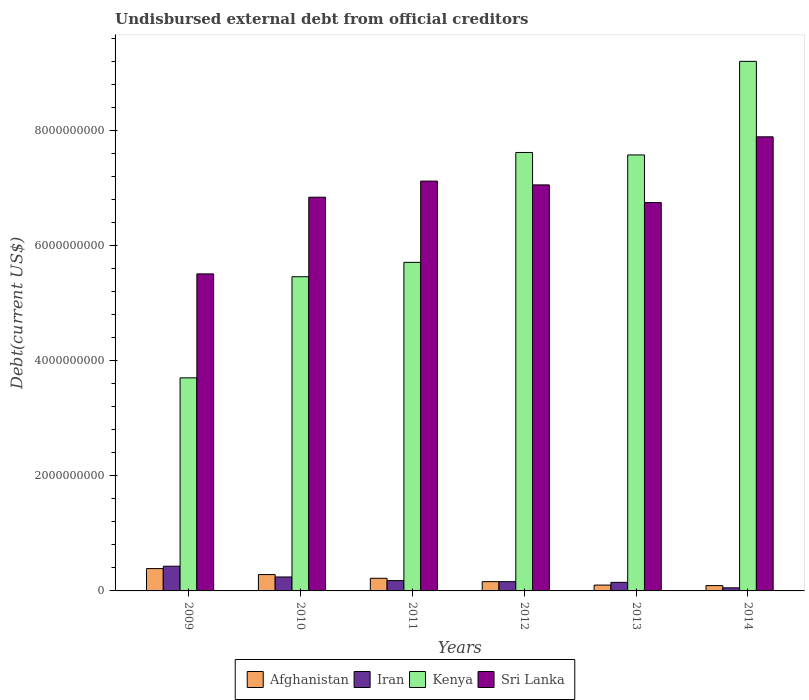How many different coloured bars are there?
Your response must be concise. 4. How many groups of bars are there?
Keep it short and to the point. 6. Are the number of bars per tick equal to the number of legend labels?
Provide a short and direct response. Yes. How many bars are there on the 1st tick from the left?
Keep it short and to the point. 4. What is the label of the 1st group of bars from the left?
Your answer should be very brief. 2009. What is the total debt in Kenya in 2009?
Offer a terse response. 3.70e+09. Across all years, what is the maximum total debt in Afghanistan?
Offer a very short reply. 3.88e+08. Across all years, what is the minimum total debt in Iran?
Provide a short and direct response. 5.37e+07. In which year was the total debt in Iran minimum?
Make the answer very short. 2014. What is the total total debt in Afghanistan in the graph?
Offer a very short reply. 1.25e+09. What is the difference between the total debt in Sri Lanka in 2013 and that in 2014?
Keep it short and to the point. -1.14e+09. What is the difference between the total debt in Sri Lanka in 2011 and the total debt in Kenya in 2014?
Provide a succinct answer. -2.08e+09. What is the average total debt in Sri Lanka per year?
Ensure brevity in your answer.  6.87e+09. In the year 2014, what is the difference between the total debt in Kenya and total debt in Iran?
Your answer should be compact. 9.15e+09. What is the ratio of the total debt in Sri Lanka in 2009 to that in 2014?
Ensure brevity in your answer.  0.7. What is the difference between the highest and the second highest total debt in Iran?
Make the answer very short. 1.87e+08. What is the difference between the highest and the lowest total debt in Iran?
Ensure brevity in your answer.  3.76e+08. What does the 4th bar from the left in 2012 represents?
Keep it short and to the point. Sri Lanka. What does the 1st bar from the right in 2009 represents?
Offer a terse response. Sri Lanka. Is it the case that in every year, the sum of the total debt in Afghanistan and total debt in Sri Lanka is greater than the total debt in Iran?
Give a very brief answer. Yes. Are all the bars in the graph horizontal?
Offer a very short reply. No. How many years are there in the graph?
Ensure brevity in your answer.  6. Are the values on the major ticks of Y-axis written in scientific E-notation?
Keep it short and to the point. No. How many legend labels are there?
Your answer should be compact. 4. What is the title of the graph?
Give a very brief answer. Undisbursed external debt from official creditors. What is the label or title of the Y-axis?
Offer a very short reply. Debt(current US$). What is the Debt(current US$) of Afghanistan in 2009?
Offer a very short reply. 3.88e+08. What is the Debt(current US$) of Iran in 2009?
Make the answer very short. 4.29e+08. What is the Debt(current US$) of Kenya in 2009?
Provide a succinct answer. 3.70e+09. What is the Debt(current US$) in Sri Lanka in 2009?
Your response must be concise. 5.51e+09. What is the Debt(current US$) in Afghanistan in 2010?
Your answer should be compact. 2.84e+08. What is the Debt(current US$) in Iran in 2010?
Offer a very short reply. 2.43e+08. What is the Debt(current US$) in Kenya in 2010?
Give a very brief answer. 5.46e+09. What is the Debt(current US$) in Sri Lanka in 2010?
Make the answer very short. 6.85e+09. What is the Debt(current US$) of Afghanistan in 2011?
Your answer should be very brief. 2.20e+08. What is the Debt(current US$) in Iran in 2011?
Make the answer very short. 1.79e+08. What is the Debt(current US$) in Kenya in 2011?
Offer a very short reply. 5.71e+09. What is the Debt(current US$) in Sri Lanka in 2011?
Provide a succinct answer. 7.13e+09. What is the Debt(current US$) of Afghanistan in 2012?
Provide a short and direct response. 1.61e+08. What is the Debt(current US$) in Iran in 2012?
Give a very brief answer. 1.61e+08. What is the Debt(current US$) of Kenya in 2012?
Make the answer very short. 7.62e+09. What is the Debt(current US$) in Sri Lanka in 2012?
Offer a terse response. 7.06e+09. What is the Debt(current US$) in Afghanistan in 2013?
Make the answer very short. 1.02e+08. What is the Debt(current US$) of Iran in 2013?
Provide a succinct answer. 1.49e+08. What is the Debt(current US$) of Kenya in 2013?
Provide a short and direct response. 7.58e+09. What is the Debt(current US$) in Sri Lanka in 2013?
Your response must be concise. 6.75e+09. What is the Debt(current US$) of Afghanistan in 2014?
Offer a very short reply. 9.24e+07. What is the Debt(current US$) in Iran in 2014?
Offer a terse response. 5.37e+07. What is the Debt(current US$) in Kenya in 2014?
Ensure brevity in your answer.  9.21e+09. What is the Debt(current US$) of Sri Lanka in 2014?
Your answer should be very brief. 7.90e+09. Across all years, what is the maximum Debt(current US$) of Afghanistan?
Make the answer very short. 3.88e+08. Across all years, what is the maximum Debt(current US$) in Iran?
Offer a very short reply. 4.29e+08. Across all years, what is the maximum Debt(current US$) of Kenya?
Provide a succinct answer. 9.21e+09. Across all years, what is the maximum Debt(current US$) in Sri Lanka?
Provide a short and direct response. 7.90e+09. Across all years, what is the minimum Debt(current US$) of Afghanistan?
Make the answer very short. 9.24e+07. Across all years, what is the minimum Debt(current US$) in Iran?
Offer a very short reply. 5.37e+07. Across all years, what is the minimum Debt(current US$) of Kenya?
Make the answer very short. 3.70e+09. Across all years, what is the minimum Debt(current US$) of Sri Lanka?
Give a very brief answer. 5.51e+09. What is the total Debt(current US$) in Afghanistan in the graph?
Your response must be concise. 1.25e+09. What is the total Debt(current US$) of Iran in the graph?
Provide a succinct answer. 1.21e+09. What is the total Debt(current US$) of Kenya in the graph?
Offer a terse response. 3.93e+1. What is the total Debt(current US$) in Sri Lanka in the graph?
Provide a short and direct response. 4.12e+1. What is the difference between the Debt(current US$) of Afghanistan in 2009 and that in 2010?
Offer a very short reply. 1.04e+08. What is the difference between the Debt(current US$) of Iran in 2009 and that in 2010?
Make the answer very short. 1.87e+08. What is the difference between the Debt(current US$) in Kenya in 2009 and that in 2010?
Give a very brief answer. -1.76e+09. What is the difference between the Debt(current US$) of Sri Lanka in 2009 and that in 2010?
Offer a very short reply. -1.33e+09. What is the difference between the Debt(current US$) of Afghanistan in 2009 and that in 2011?
Ensure brevity in your answer.  1.68e+08. What is the difference between the Debt(current US$) in Iran in 2009 and that in 2011?
Offer a terse response. 2.50e+08. What is the difference between the Debt(current US$) of Kenya in 2009 and that in 2011?
Offer a terse response. -2.01e+09. What is the difference between the Debt(current US$) of Sri Lanka in 2009 and that in 2011?
Your answer should be compact. -1.61e+09. What is the difference between the Debt(current US$) of Afghanistan in 2009 and that in 2012?
Your answer should be compact. 2.27e+08. What is the difference between the Debt(current US$) of Iran in 2009 and that in 2012?
Ensure brevity in your answer.  2.68e+08. What is the difference between the Debt(current US$) in Kenya in 2009 and that in 2012?
Your answer should be compact. -3.92e+09. What is the difference between the Debt(current US$) in Sri Lanka in 2009 and that in 2012?
Provide a short and direct response. -1.55e+09. What is the difference between the Debt(current US$) of Afghanistan in 2009 and that in 2013?
Offer a terse response. 2.87e+08. What is the difference between the Debt(current US$) of Iran in 2009 and that in 2013?
Offer a very short reply. 2.80e+08. What is the difference between the Debt(current US$) in Kenya in 2009 and that in 2013?
Give a very brief answer. -3.88e+09. What is the difference between the Debt(current US$) in Sri Lanka in 2009 and that in 2013?
Ensure brevity in your answer.  -1.24e+09. What is the difference between the Debt(current US$) in Afghanistan in 2009 and that in 2014?
Your response must be concise. 2.96e+08. What is the difference between the Debt(current US$) of Iran in 2009 and that in 2014?
Make the answer very short. 3.76e+08. What is the difference between the Debt(current US$) of Kenya in 2009 and that in 2014?
Provide a succinct answer. -5.50e+09. What is the difference between the Debt(current US$) in Sri Lanka in 2009 and that in 2014?
Provide a short and direct response. -2.38e+09. What is the difference between the Debt(current US$) of Afghanistan in 2010 and that in 2011?
Offer a terse response. 6.44e+07. What is the difference between the Debt(current US$) of Iran in 2010 and that in 2011?
Give a very brief answer. 6.32e+07. What is the difference between the Debt(current US$) of Kenya in 2010 and that in 2011?
Provide a succinct answer. -2.50e+08. What is the difference between the Debt(current US$) of Sri Lanka in 2010 and that in 2011?
Give a very brief answer. -2.80e+08. What is the difference between the Debt(current US$) of Afghanistan in 2010 and that in 2012?
Provide a short and direct response. 1.23e+08. What is the difference between the Debt(current US$) of Iran in 2010 and that in 2012?
Offer a very short reply. 8.17e+07. What is the difference between the Debt(current US$) in Kenya in 2010 and that in 2012?
Make the answer very short. -2.16e+09. What is the difference between the Debt(current US$) of Sri Lanka in 2010 and that in 2012?
Offer a very short reply. -2.14e+08. What is the difference between the Debt(current US$) of Afghanistan in 2010 and that in 2013?
Provide a short and direct response. 1.83e+08. What is the difference between the Debt(current US$) in Iran in 2010 and that in 2013?
Ensure brevity in your answer.  9.35e+07. What is the difference between the Debt(current US$) of Kenya in 2010 and that in 2013?
Give a very brief answer. -2.12e+09. What is the difference between the Debt(current US$) of Sri Lanka in 2010 and that in 2013?
Your answer should be very brief. 9.24e+07. What is the difference between the Debt(current US$) of Afghanistan in 2010 and that in 2014?
Give a very brief answer. 1.92e+08. What is the difference between the Debt(current US$) in Iran in 2010 and that in 2014?
Ensure brevity in your answer.  1.89e+08. What is the difference between the Debt(current US$) in Kenya in 2010 and that in 2014?
Provide a short and direct response. -3.74e+09. What is the difference between the Debt(current US$) of Sri Lanka in 2010 and that in 2014?
Offer a terse response. -1.05e+09. What is the difference between the Debt(current US$) in Afghanistan in 2011 and that in 2012?
Provide a succinct answer. 5.87e+07. What is the difference between the Debt(current US$) of Iran in 2011 and that in 2012?
Provide a succinct answer. 1.85e+07. What is the difference between the Debt(current US$) of Kenya in 2011 and that in 2012?
Provide a succinct answer. -1.91e+09. What is the difference between the Debt(current US$) of Sri Lanka in 2011 and that in 2012?
Make the answer very short. 6.60e+07. What is the difference between the Debt(current US$) in Afghanistan in 2011 and that in 2013?
Your answer should be very brief. 1.18e+08. What is the difference between the Debt(current US$) of Iran in 2011 and that in 2013?
Your response must be concise. 3.02e+07. What is the difference between the Debt(current US$) of Kenya in 2011 and that in 2013?
Ensure brevity in your answer.  -1.87e+09. What is the difference between the Debt(current US$) of Sri Lanka in 2011 and that in 2013?
Your answer should be compact. 3.73e+08. What is the difference between the Debt(current US$) of Afghanistan in 2011 and that in 2014?
Give a very brief answer. 1.28e+08. What is the difference between the Debt(current US$) of Iran in 2011 and that in 2014?
Make the answer very short. 1.26e+08. What is the difference between the Debt(current US$) of Kenya in 2011 and that in 2014?
Ensure brevity in your answer.  -3.49e+09. What is the difference between the Debt(current US$) of Sri Lanka in 2011 and that in 2014?
Offer a terse response. -7.70e+08. What is the difference between the Debt(current US$) of Afghanistan in 2012 and that in 2013?
Offer a terse response. 5.97e+07. What is the difference between the Debt(current US$) of Iran in 2012 and that in 2013?
Your response must be concise. 1.17e+07. What is the difference between the Debt(current US$) of Kenya in 2012 and that in 2013?
Make the answer very short. 4.27e+07. What is the difference between the Debt(current US$) of Sri Lanka in 2012 and that in 2013?
Provide a succinct answer. 3.07e+08. What is the difference between the Debt(current US$) in Afghanistan in 2012 and that in 2014?
Your response must be concise. 6.89e+07. What is the difference between the Debt(current US$) of Iran in 2012 and that in 2014?
Offer a very short reply. 1.07e+08. What is the difference between the Debt(current US$) of Kenya in 2012 and that in 2014?
Give a very brief answer. -1.58e+09. What is the difference between the Debt(current US$) of Sri Lanka in 2012 and that in 2014?
Your answer should be compact. -8.36e+08. What is the difference between the Debt(current US$) of Afghanistan in 2013 and that in 2014?
Your answer should be compact. 9.12e+06. What is the difference between the Debt(current US$) of Iran in 2013 and that in 2014?
Your answer should be compact. 9.54e+07. What is the difference between the Debt(current US$) in Kenya in 2013 and that in 2014?
Your answer should be very brief. -1.63e+09. What is the difference between the Debt(current US$) of Sri Lanka in 2013 and that in 2014?
Your answer should be very brief. -1.14e+09. What is the difference between the Debt(current US$) in Afghanistan in 2009 and the Debt(current US$) in Iran in 2010?
Ensure brevity in your answer.  1.46e+08. What is the difference between the Debt(current US$) in Afghanistan in 2009 and the Debt(current US$) in Kenya in 2010?
Provide a short and direct response. -5.07e+09. What is the difference between the Debt(current US$) of Afghanistan in 2009 and the Debt(current US$) of Sri Lanka in 2010?
Provide a short and direct response. -6.46e+09. What is the difference between the Debt(current US$) of Iran in 2009 and the Debt(current US$) of Kenya in 2010?
Offer a terse response. -5.03e+09. What is the difference between the Debt(current US$) in Iran in 2009 and the Debt(current US$) in Sri Lanka in 2010?
Ensure brevity in your answer.  -6.42e+09. What is the difference between the Debt(current US$) of Kenya in 2009 and the Debt(current US$) of Sri Lanka in 2010?
Provide a short and direct response. -3.14e+09. What is the difference between the Debt(current US$) of Afghanistan in 2009 and the Debt(current US$) of Iran in 2011?
Offer a very short reply. 2.09e+08. What is the difference between the Debt(current US$) in Afghanistan in 2009 and the Debt(current US$) in Kenya in 2011?
Keep it short and to the point. -5.32e+09. What is the difference between the Debt(current US$) in Afghanistan in 2009 and the Debt(current US$) in Sri Lanka in 2011?
Your answer should be compact. -6.74e+09. What is the difference between the Debt(current US$) in Iran in 2009 and the Debt(current US$) in Kenya in 2011?
Your answer should be compact. -5.28e+09. What is the difference between the Debt(current US$) in Iran in 2009 and the Debt(current US$) in Sri Lanka in 2011?
Provide a succinct answer. -6.70e+09. What is the difference between the Debt(current US$) of Kenya in 2009 and the Debt(current US$) of Sri Lanka in 2011?
Your response must be concise. -3.42e+09. What is the difference between the Debt(current US$) of Afghanistan in 2009 and the Debt(current US$) of Iran in 2012?
Provide a succinct answer. 2.28e+08. What is the difference between the Debt(current US$) of Afghanistan in 2009 and the Debt(current US$) of Kenya in 2012?
Keep it short and to the point. -7.24e+09. What is the difference between the Debt(current US$) of Afghanistan in 2009 and the Debt(current US$) of Sri Lanka in 2012?
Your response must be concise. -6.67e+09. What is the difference between the Debt(current US$) in Iran in 2009 and the Debt(current US$) in Kenya in 2012?
Make the answer very short. -7.19e+09. What is the difference between the Debt(current US$) in Iran in 2009 and the Debt(current US$) in Sri Lanka in 2012?
Your answer should be very brief. -6.63e+09. What is the difference between the Debt(current US$) of Kenya in 2009 and the Debt(current US$) of Sri Lanka in 2012?
Provide a short and direct response. -3.35e+09. What is the difference between the Debt(current US$) in Afghanistan in 2009 and the Debt(current US$) in Iran in 2013?
Provide a succinct answer. 2.39e+08. What is the difference between the Debt(current US$) of Afghanistan in 2009 and the Debt(current US$) of Kenya in 2013?
Ensure brevity in your answer.  -7.19e+09. What is the difference between the Debt(current US$) of Afghanistan in 2009 and the Debt(current US$) of Sri Lanka in 2013?
Keep it short and to the point. -6.36e+09. What is the difference between the Debt(current US$) of Iran in 2009 and the Debt(current US$) of Kenya in 2013?
Give a very brief answer. -7.15e+09. What is the difference between the Debt(current US$) in Iran in 2009 and the Debt(current US$) in Sri Lanka in 2013?
Your answer should be very brief. -6.32e+09. What is the difference between the Debt(current US$) in Kenya in 2009 and the Debt(current US$) in Sri Lanka in 2013?
Your answer should be compact. -3.05e+09. What is the difference between the Debt(current US$) in Afghanistan in 2009 and the Debt(current US$) in Iran in 2014?
Make the answer very short. 3.35e+08. What is the difference between the Debt(current US$) in Afghanistan in 2009 and the Debt(current US$) in Kenya in 2014?
Give a very brief answer. -8.82e+09. What is the difference between the Debt(current US$) of Afghanistan in 2009 and the Debt(current US$) of Sri Lanka in 2014?
Your answer should be very brief. -7.51e+09. What is the difference between the Debt(current US$) of Iran in 2009 and the Debt(current US$) of Kenya in 2014?
Ensure brevity in your answer.  -8.78e+09. What is the difference between the Debt(current US$) in Iran in 2009 and the Debt(current US$) in Sri Lanka in 2014?
Offer a terse response. -7.47e+09. What is the difference between the Debt(current US$) in Kenya in 2009 and the Debt(current US$) in Sri Lanka in 2014?
Offer a terse response. -4.19e+09. What is the difference between the Debt(current US$) of Afghanistan in 2010 and the Debt(current US$) of Iran in 2011?
Your answer should be very brief. 1.05e+08. What is the difference between the Debt(current US$) in Afghanistan in 2010 and the Debt(current US$) in Kenya in 2011?
Ensure brevity in your answer.  -5.43e+09. What is the difference between the Debt(current US$) in Afghanistan in 2010 and the Debt(current US$) in Sri Lanka in 2011?
Keep it short and to the point. -6.84e+09. What is the difference between the Debt(current US$) of Iran in 2010 and the Debt(current US$) of Kenya in 2011?
Provide a succinct answer. -5.47e+09. What is the difference between the Debt(current US$) in Iran in 2010 and the Debt(current US$) in Sri Lanka in 2011?
Keep it short and to the point. -6.88e+09. What is the difference between the Debt(current US$) in Kenya in 2010 and the Debt(current US$) in Sri Lanka in 2011?
Offer a very short reply. -1.66e+09. What is the difference between the Debt(current US$) in Afghanistan in 2010 and the Debt(current US$) in Iran in 2012?
Keep it short and to the point. 1.24e+08. What is the difference between the Debt(current US$) of Afghanistan in 2010 and the Debt(current US$) of Kenya in 2012?
Your answer should be compact. -7.34e+09. What is the difference between the Debt(current US$) of Afghanistan in 2010 and the Debt(current US$) of Sri Lanka in 2012?
Keep it short and to the point. -6.78e+09. What is the difference between the Debt(current US$) of Iran in 2010 and the Debt(current US$) of Kenya in 2012?
Keep it short and to the point. -7.38e+09. What is the difference between the Debt(current US$) of Iran in 2010 and the Debt(current US$) of Sri Lanka in 2012?
Make the answer very short. -6.82e+09. What is the difference between the Debt(current US$) of Kenya in 2010 and the Debt(current US$) of Sri Lanka in 2012?
Give a very brief answer. -1.60e+09. What is the difference between the Debt(current US$) in Afghanistan in 2010 and the Debt(current US$) in Iran in 2013?
Make the answer very short. 1.35e+08. What is the difference between the Debt(current US$) in Afghanistan in 2010 and the Debt(current US$) in Kenya in 2013?
Make the answer very short. -7.30e+09. What is the difference between the Debt(current US$) in Afghanistan in 2010 and the Debt(current US$) in Sri Lanka in 2013?
Your response must be concise. -6.47e+09. What is the difference between the Debt(current US$) in Iran in 2010 and the Debt(current US$) in Kenya in 2013?
Offer a very short reply. -7.34e+09. What is the difference between the Debt(current US$) of Iran in 2010 and the Debt(current US$) of Sri Lanka in 2013?
Offer a very short reply. -6.51e+09. What is the difference between the Debt(current US$) of Kenya in 2010 and the Debt(current US$) of Sri Lanka in 2013?
Provide a succinct answer. -1.29e+09. What is the difference between the Debt(current US$) of Afghanistan in 2010 and the Debt(current US$) of Iran in 2014?
Offer a very short reply. 2.31e+08. What is the difference between the Debt(current US$) in Afghanistan in 2010 and the Debt(current US$) in Kenya in 2014?
Your answer should be compact. -8.92e+09. What is the difference between the Debt(current US$) in Afghanistan in 2010 and the Debt(current US$) in Sri Lanka in 2014?
Provide a succinct answer. -7.61e+09. What is the difference between the Debt(current US$) in Iran in 2010 and the Debt(current US$) in Kenya in 2014?
Provide a succinct answer. -8.97e+09. What is the difference between the Debt(current US$) of Iran in 2010 and the Debt(current US$) of Sri Lanka in 2014?
Your answer should be very brief. -7.65e+09. What is the difference between the Debt(current US$) of Kenya in 2010 and the Debt(current US$) of Sri Lanka in 2014?
Provide a succinct answer. -2.43e+09. What is the difference between the Debt(current US$) of Afghanistan in 2011 and the Debt(current US$) of Iran in 2012?
Provide a short and direct response. 5.92e+07. What is the difference between the Debt(current US$) of Afghanistan in 2011 and the Debt(current US$) of Kenya in 2012?
Offer a terse response. -7.40e+09. What is the difference between the Debt(current US$) in Afghanistan in 2011 and the Debt(current US$) in Sri Lanka in 2012?
Ensure brevity in your answer.  -6.84e+09. What is the difference between the Debt(current US$) of Iran in 2011 and the Debt(current US$) of Kenya in 2012?
Offer a very short reply. -7.44e+09. What is the difference between the Debt(current US$) in Iran in 2011 and the Debt(current US$) in Sri Lanka in 2012?
Ensure brevity in your answer.  -6.88e+09. What is the difference between the Debt(current US$) of Kenya in 2011 and the Debt(current US$) of Sri Lanka in 2012?
Your answer should be compact. -1.35e+09. What is the difference between the Debt(current US$) of Afghanistan in 2011 and the Debt(current US$) of Iran in 2013?
Provide a short and direct response. 7.09e+07. What is the difference between the Debt(current US$) of Afghanistan in 2011 and the Debt(current US$) of Kenya in 2013?
Your answer should be compact. -7.36e+09. What is the difference between the Debt(current US$) of Afghanistan in 2011 and the Debt(current US$) of Sri Lanka in 2013?
Keep it short and to the point. -6.53e+09. What is the difference between the Debt(current US$) in Iran in 2011 and the Debt(current US$) in Kenya in 2013?
Give a very brief answer. -7.40e+09. What is the difference between the Debt(current US$) in Iran in 2011 and the Debt(current US$) in Sri Lanka in 2013?
Offer a very short reply. -6.57e+09. What is the difference between the Debt(current US$) of Kenya in 2011 and the Debt(current US$) of Sri Lanka in 2013?
Ensure brevity in your answer.  -1.04e+09. What is the difference between the Debt(current US$) in Afghanistan in 2011 and the Debt(current US$) in Iran in 2014?
Give a very brief answer. 1.66e+08. What is the difference between the Debt(current US$) of Afghanistan in 2011 and the Debt(current US$) of Kenya in 2014?
Keep it short and to the point. -8.99e+09. What is the difference between the Debt(current US$) in Afghanistan in 2011 and the Debt(current US$) in Sri Lanka in 2014?
Make the answer very short. -7.68e+09. What is the difference between the Debt(current US$) in Iran in 2011 and the Debt(current US$) in Kenya in 2014?
Provide a short and direct response. -9.03e+09. What is the difference between the Debt(current US$) in Iran in 2011 and the Debt(current US$) in Sri Lanka in 2014?
Your answer should be very brief. -7.72e+09. What is the difference between the Debt(current US$) of Kenya in 2011 and the Debt(current US$) of Sri Lanka in 2014?
Provide a short and direct response. -2.18e+09. What is the difference between the Debt(current US$) in Afghanistan in 2012 and the Debt(current US$) in Iran in 2013?
Offer a very short reply. 1.22e+07. What is the difference between the Debt(current US$) of Afghanistan in 2012 and the Debt(current US$) of Kenya in 2013?
Give a very brief answer. -7.42e+09. What is the difference between the Debt(current US$) of Afghanistan in 2012 and the Debt(current US$) of Sri Lanka in 2013?
Your answer should be very brief. -6.59e+09. What is the difference between the Debt(current US$) in Iran in 2012 and the Debt(current US$) in Kenya in 2013?
Your answer should be compact. -7.42e+09. What is the difference between the Debt(current US$) of Iran in 2012 and the Debt(current US$) of Sri Lanka in 2013?
Your answer should be compact. -6.59e+09. What is the difference between the Debt(current US$) of Kenya in 2012 and the Debt(current US$) of Sri Lanka in 2013?
Offer a terse response. 8.70e+08. What is the difference between the Debt(current US$) of Afghanistan in 2012 and the Debt(current US$) of Iran in 2014?
Give a very brief answer. 1.08e+08. What is the difference between the Debt(current US$) in Afghanistan in 2012 and the Debt(current US$) in Kenya in 2014?
Your answer should be very brief. -9.05e+09. What is the difference between the Debt(current US$) in Afghanistan in 2012 and the Debt(current US$) in Sri Lanka in 2014?
Ensure brevity in your answer.  -7.73e+09. What is the difference between the Debt(current US$) in Iran in 2012 and the Debt(current US$) in Kenya in 2014?
Provide a succinct answer. -9.05e+09. What is the difference between the Debt(current US$) in Iran in 2012 and the Debt(current US$) in Sri Lanka in 2014?
Your answer should be very brief. -7.73e+09. What is the difference between the Debt(current US$) in Kenya in 2012 and the Debt(current US$) in Sri Lanka in 2014?
Ensure brevity in your answer.  -2.72e+08. What is the difference between the Debt(current US$) of Afghanistan in 2013 and the Debt(current US$) of Iran in 2014?
Offer a very short reply. 4.79e+07. What is the difference between the Debt(current US$) in Afghanistan in 2013 and the Debt(current US$) in Kenya in 2014?
Give a very brief answer. -9.11e+09. What is the difference between the Debt(current US$) in Afghanistan in 2013 and the Debt(current US$) in Sri Lanka in 2014?
Your response must be concise. -7.79e+09. What is the difference between the Debt(current US$) in Iran in 2013 and the Debt(current US$) in Kenya in 2014?
Keep it short and to the point. -9.06e+09. What is the difference between the Debt(current US$) of Iran in 2013 and the Debt(current US$) of Sri Lanka in 2014?
Offer a very short reply. -7.75e+09. What is the difference between the Debt(current US$) in Kenya in 2013 and the Debt(current US$) in Sri Lanka in 2014?
Offer a terse response. -3.15e+08. What is the average Debt(current US$) of Afghanistan per year?
Your answer should be compact. 2.08e+08. What is the average Debt(current US$) in Iran per year?
Offer a terse response. 2.02e+08. What is the average Debt(current US$) in Kenya per year?
Make the answer very short. 6.55e+09. What is the average Debt(current US$) of Sri Lanka per year?
Your answer should be compact. 6.87e+09. In the year 2009, what is the difference between the Debt(current US$) of Afghanistan and Debt(current US$) of Iran?
Keep it short and to the point. -4.10e+07. In the year 2009, what is the difference between the Debt(current US$) of Afghanistan and Debt(current US$) of Kenya?
Your answer should be compact. -3.32e+09. In the year 2009, what is the difference between the Debt(current US$) in Afghanistan and Debt(current US$) in Sri Lanka?
Keep it short and to the point. -5.12e+09. In the year 2009, what is the difference between the Debt(current US$) in Iran and Debt(current US$) in Kenya?
Provide a succinct answer. -3.28e+09. In the year 2009, what is the difference between the Debt(current US$) in Iran and Debt(current US$) in Sri Lanka?
Make the answer very short. -5.08e+09. In the year 2009, what is the difference between the Debt(current US$) in Kenya and Debt(current US$) in Sri Lanka?
Keep it short and to the point. -1.81e+09. In the year 2010, what is the difference between the Debt(current US$) of Afghanistan and Debt(current US$) of Iran?
Make the answer very short. 4.19e+07. In the year 2010, what is the difference between the Debt(current US$) of Afghanistan and Debt(current US$) of Kenya?
Provide a succinct answer. -5.18e+09. In the year 2010, what is the difference between the Debt(current US$) of Afghanistan and Debt(current US$) of Sri Lanka?
Make the answer very short. -6.56e+09. In the year 2010, what is the difference between the Debt(current US$) of Iran and Debt(current US$) of Kenya?
Offer a terse response. -5.22e+09. In the year 2010, what is the difference between the Debt(current US$) in Iran and Debt(current US$) in Sri Lanka?
Provide a short and direct response. -6.60e+09. In the year 2010, what is the difference between the Debt(current US$) in Kenya and Debt(current US$) in Sri Lanka?
Your answer should be very brief. -1.38e+09. In the year 2011, what is the difference between the Debt(current US$) in Afghanistan and Debt(current US$) in Iran?
Your response must be concise. 4.07e+07. In the year 2011, what is the difference between the Debt(current US$) in Afghanistan and Debt(current US$) in Kenya?
Ensure brevity in your answer.  -5.49e+09. In the year 2011, what is the difference between the Debt(current US$) in Afghanistan and Debt(current US$) in Sri Lanka?
Provide a short and direct response. -6.91e+09. In the year 2011, what is the difference between the Debt(current US$) of Iran and Debt(current US$) of Kenya?
Keep it short and to the point. -5.53e+09. In the year 2011, what is the difference between the Debt(current US$) of Iran and Debt(current US$) of Sri Lanka?
Ensure brevity in your answer.  -6.95e+09. In the year 2011, what is the difference between the Debt(current US$) in Kenya and Debt(current US$) in Sri Lanka?
Give a very brief answer. -1.41e+09. In the year 2012, what is the difference between the Debt(current US$) of Afghanistan and Debt(current US$) of Iran?
Ensure brevity in your answer.  4.31e+05. In the year 2012, what is the difference between the Debt(current US$) of Afghanistan and Debt(current US$) of Kenya?
Ensure brevity in your answer.  -7.46e+09. In the year 2012, what is the difference between the Debt(current US$) in Afghanistan and Debt(current US$) in Sri Lanka?
Keep it short and to the point. -6.90e+09. In the year 2012, what is the difference between the Debt(current US$) of Iran and Debt(current US$) of Kenya?
Your response must be concise. -7.46e+09. In the year 2012, what is the difference between the Debt(current US$) of Iran and Debt(current US$) of Sri Lanka?
Offer a terse response. -6.90e+09. In the year 2012, what is the difference between the Debt(current US$) in Kenya and Debt(current US$) in Sri Lanka?
Your answer should be compact. 5.64e+08. In the year 2013, what is the difference between the Debt(current US$) in Afghanistan and Debt(current US$) in Iran?
Provide a succinct answer. -4.76e+07. In the year 2013, what is the difference between the Debt(current US$) in Afghanistan and Debt(current US$) in Kenya?
Provide a succinct answer. -7.48e+09. In the year 2013, what is the difference between the Debt(current US$) in Afghanistan and Debt(current US$) in Sri Lanka?
Your answer should be very brief. -6.65e+09. In the year 2013, what is the difference between the Debt(current US$) in Iran and Debt(current US$) in Kenya?
Your response must be concise. -7.43e+09. In the year 2013, what is the difference between the Debt(current US$) in Iran and Debt(current US$) in Sri Lanka?
Make the answer very short. -6.60e+09. In the year 2013, what is the difference between the Debt(current US$) of Kenya and Debt(current US$) of Sri Lanka?
Provide a short and direct response. 8.28e+08. In the year 2014, what is the difference between the Debt(current US$) in Afghanistan and Debt(current US$) in Iran?
Your answer should be very brief. 3.87e+07. In the year 2014, what is the difference between the Debt(current US$) of Afghanistan and Debt(current US$) of Kenya?
Offer a very short reply. -9.12e+09. In the year 2014, what is the difference between the Debt(current US$) of Afghanistan and Debt(current US$) of Sri Lanka?
Offer a terse response. -7.80e+09. In the year 2014, what is the difference between the Debt(current US$) in Iran and Debt(current US$) in Kenya?
Your answer should be compact. -9.15e+09. In the year 2014, what is the difference between the Debt(current US$) of Iran and Debt(current US$) of Sri Lanka?
Provide a succinct answer. -7.84e+09. In the year 2014, what is the difference between the Debt(current US$) in Kenya and Debt(current US$) in Sri Lanka?
Provide a short and direct response. 1.31e+09. What is the ratio of the Debt(current US$) in Afghanistan in 2009 to that in 2010?
Your response must be concise. 1.37. What is the ratio of the Debt(current US$) in Iran in 2009 to that in 2010?
Keep it short and to the point. 1.77. What is the ratio of the Debt(current US$) in Kenya in 2009 to that in 2010?
Offer a terse response. 0.68. What is the ratio of the Debt(current US$) in Sri Lanka in 2009 to that in 2010?
Offer a very short reply. 0.81. What is the ratio of the Debt(current US$) of Afghanistan in 2009 to that in 2011?
Your response must be concise. 1.77. What is the ratio of the Debt(current US$) in Iran in 2009 to that in 2011?
Offer a terse response. 2.39. What is the ratio of the Debt(current US$) of Kenya in 2009 to that in 2011?
Your answer should be compact. 0.65. What is the ratio of the Debt(current US$) in Sri Lanka in 2009 to that in 2011?
Make the answer very short. 0.77. What is the ratio of the Debt(current US$) in Afghanistan in 2009 to that in 2012?
Provide a succinct answer. 2.41. What is the ratio of the Debt(current US$) in Iran in 2009 to that in 2012?
Offer a terse response. 2.67. What is the ratio of the Debt(current US$) of Kenya in 2009 to that in 2012?
Your answer should be compact. 0.49. What is the ratio of the Debt(current US$) of Sri Lanka in 2009 to that in 2012?
Ensure brevity in your answer.  0.78. What is the ratio of the Debt(current US$) of Afghanistan in 2009 to that in 2013?
Make the answer very short. 3.83. What is the ratio of the Debt(current US$) of Iran in 2009 to that in 2013?
Your answer should be compact. 2.88. What is the ratio of the Debt(current US$) in Kenya in 2009 to that in 2013?
Your answer should be very brief. 0.49. What is the ratio of the Debt(current US$) in Sri Lanka in 2009 to that in 2013?
Your answer should be very brief. 0.82. What is the ratio of the Debt(current US$) of Afghanistan in 2009 to that in 2014?
Provide a short and direct response. 4.2. What is the ratio of the Debt(current US$) in Iran in 2009 to that in 2014?
Offer a very short reply. 8. What is the ratio of the Debt(current US$) in Kenya in 2009 to that in 2014?
Ensure brevity in your answer.  0.4. What is the ratio of the Debt(current US$) in Sri Lanka in 2009 to that in 2014?
Provide a short and direct response. 0.7. What is the ratio of the Debt(current US$) of Afghanistan in 2010 to that in 2011?
Give a very brief answer. 1.29. What is the ratio of the Debt(current US$) in Iran in 2010 to that in 2011?
Make the answer very short. 1.35. What is the ratio of the Debt(current US$) in Kenya in 2010 to that in 2011?
Offer a terse response. 0.96. What is the ratio of the Debt(current US$) of Sri Lanka in 2010 to that in 2011?
Make the answer very short. 0.96. What is the ratio of the Debt(current US$) in Afghanistan in 2010 to that in 2012?
Provide a succinct answer. 1.76. What is the ratio of the Debt(current US$) of Iran in 2010 to that in 2012?
Offer a very short reply. 1.51. What is the ratio of the Debt(current US$) in Kenya in 2010 to that in 2012?
Ensure brevity in your answer.  0.72. What is the ratio of the Debt(current US$) in Sri Lanka in 2010 to that in 2012?
Keep it short and to the point. 0.97. What is the ratio of the Debt(current US$) in Afghanistan in 2010 to that in 2013?
Your answer should be compact. 2.8. What is the ratio of the Debt(current US$) of Iran in 2010 to that in 2013?
Make the answer very short. 1.63. What is the ratio of the Debt(current US$) in Kenya in 2010 to that in 2013?
Your response must be concise. 0.72. What is the ratio of the Debt(current US$) of Sri Lanka in 2010 to that in 2013?
Your answer should be very brief. 1.01. What is the ratio of the Debt(current US$) of Afghanistan in 2010 to that in 2014?
Ensure brevity in your answer.  3.08. What is the ratio of the Debt(current US$) in Iran in 2010 to that in 2014?
Provide a short and direct response. 4.52. What is the ratio of the Debt(current US$) of Kenya in 2010 to that in 2014?
Ensure brevity in your answer.  0.59. What is the ratio of the Debt(current US$) in Sri Lanka in 2010 to that in 2014?
Your answer should be very brief. 0.87. What is the ratio of the Debt(current US$) in Afghanistan in 2011 to that in 2012?
Make the answer very short. 1.36. What is the ratio of the Debt(current US$) in Iran in 2011 to that in 2012?
Keep it short and to the point. 1.11. What is the ratio of the Debt(current US$) of Kenya in 2011 to that in 2012?
Give a very brief answer. 0.75. What is the ratio of the Debt(current US$) in Sri Lanka in 2011 to that in 2012?
Provide a short and direct response. 1.01. What is the ratio of the Debt(current US$) in Afghanistan in 2011 to that in 2013?
Ensure brevity in your answer.  2.17. What is the ratio of the Debt(current US$) in Iran in 2011 to that in 2013?
Your answer should be very brief. 1.2. What is the ratio of the Debt(current US$) in Kenya in 2011 to that in 2013?
Give a very brief answer. 0.75. What is the ratio of the Debt(current US$) of Sri Lanka in 2011 to that in 2013?
Your answer should be very brief. 1.06. What is the ratio of the Debt(current US$) of Afghanistan in 2011 to that in 2014?
Offer a very short reply. 2.38. What is the ratio of the Debt(current US$) in Iran in 2011 to that in 2014?
Your response must be concise. 3.34. What is the ratio of the Debt(current US$) of Kenya in 2011 to that in 2014?
Offer a very short reply. 0.62. What is the ratio of the Debt(current US$) in Sri Lanka in 2011 to that in 2014?
Your answer should be very brief. 0.9. What is the ratio of the Debt(current US$) in Afghanistan in 2012 to that in 2013?
Make the answer very short. 1.59. What is the ratio of the Debt(current US$) of Iran in 2012 to that in 2013?
Provide a short and direct response. 1.08. What is the ratio of the Debt(current US$) of Kenya in 2012 to that in 2013?
Offer a very short reply. 1.01. What is the ratio of the Debt(current US$) of Sri Lanka in 2012 to that in 2013?
Your answer should be compact. 1.05. What is the ratio of the Debt(current US$) of Afghanistan in 2012 to that in 2014?
Offer a very short reply. 1.75. What is the ratio of the Debt(current US$) of Iran in 2012 to that in 2014?
Your answer should be compact. 3. What is the ratio of the Debt(current US$) in Kenya in 2012 to that in 2014?
Offer a very short reply. 0.83. What is the ratio of the Debt(current US$) of Sri Lanka in 2012 to that in 2014?
Make the answer very short. 0.89. What is the ratio of the Debt(current US$) in Afghanistan in 2013 to that in 2014?
Offer a very short reply. 1.1. What is the ratio of the Debt(current US$) of Iran in 2013 to that in 2014?
Offer a terse response. 2.78. What is the ratio of the Debt(current US$) in Kenya in 2013 to that in 2014?
Your answer should be compact. 0.82. What is the ratio of the Debt(current US$) of Sri Lanka in 2013 to that in 2014?
Keep it short and to the point. 0.86. What is the difference between the highest and the second highest Debt(current US$) of Afghanistan?
Offer a terse response. 1.04e+08. What is the difference between the highest and the second highest Debt(current US$) in Iran?
Provide a succinct answer. 1.87e+08. What is the difference between the highest and the second highest Debt(current US$) of Kenya?
Your answer should be very brief. 1.58e+09. What is the difference between the highest and the second highest Debt(current US$) in Sri Lanka?
Keep it short and to the point. 7.70e+08. What is the difference between the highest and the lowest Debt(current US$) of Afghanistan?
Your answer should be compact. 2.96e+08. What is the difference between the highest and the lowest Debt(current US$) of Iran?
Ensure brevity in your answer.  3.76e+08. What is the difference between the highest and the lowest Debt(current US$) in Kenya?
Offer a very short reply. 5.50e+09. What is the difference between the highest and the lowest Debt(current US$) of Sri Lanka?
Provide a succinct answer. 2.38e+09. 